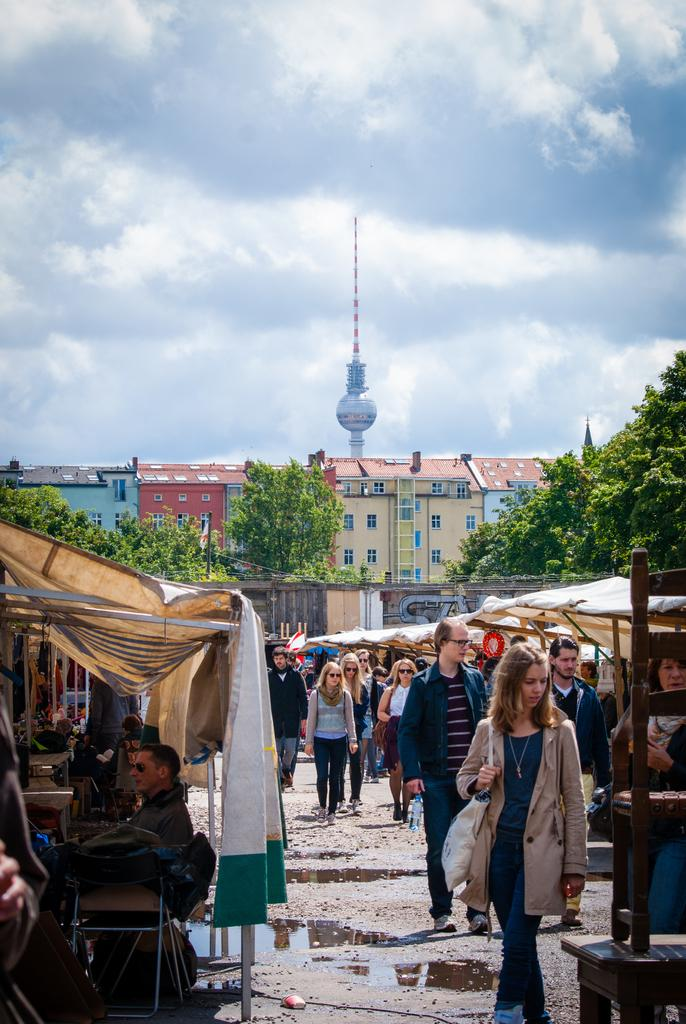What type of structures are present in the image? There are stalls in the image. What are the people in the image doing? People are walking in front of the stalls. What can be seen in the background of the image? There are many trees in the background of the image. What is located behind the trees in the background? There are buildings behind the trees in the background. What type of substance is being sold at the mailbox in the image? There is no mailbox present in the image, so it is not possible to determine what, if any, substance might be sold there. 